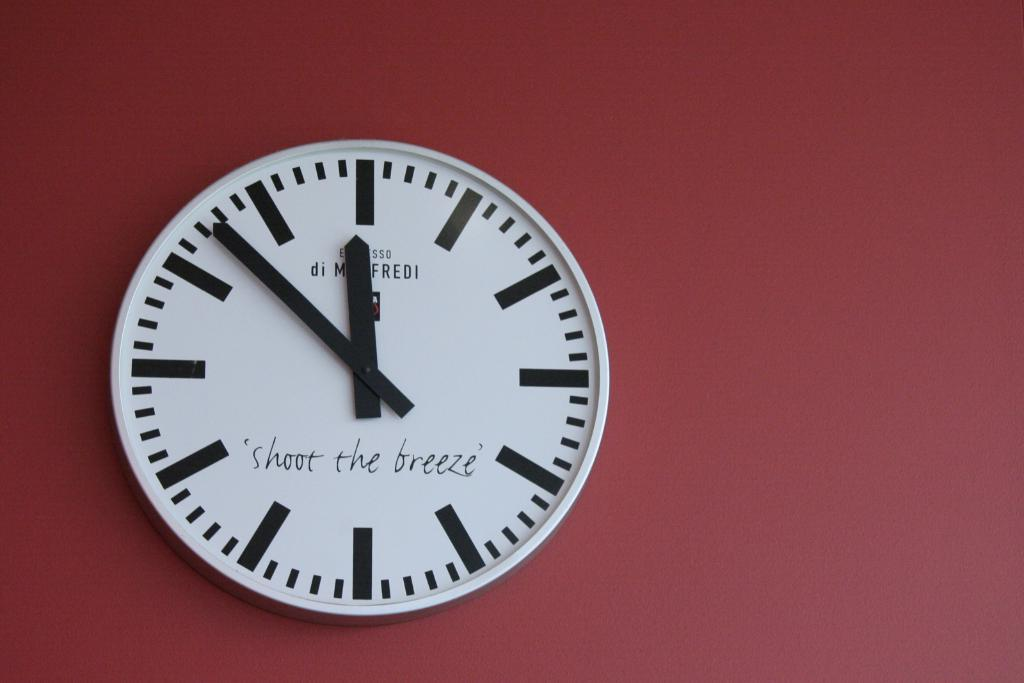<image>
Give a short and clear explanation of the subsequent image. A clock that says "shoot the breeze" sits against a red wall 